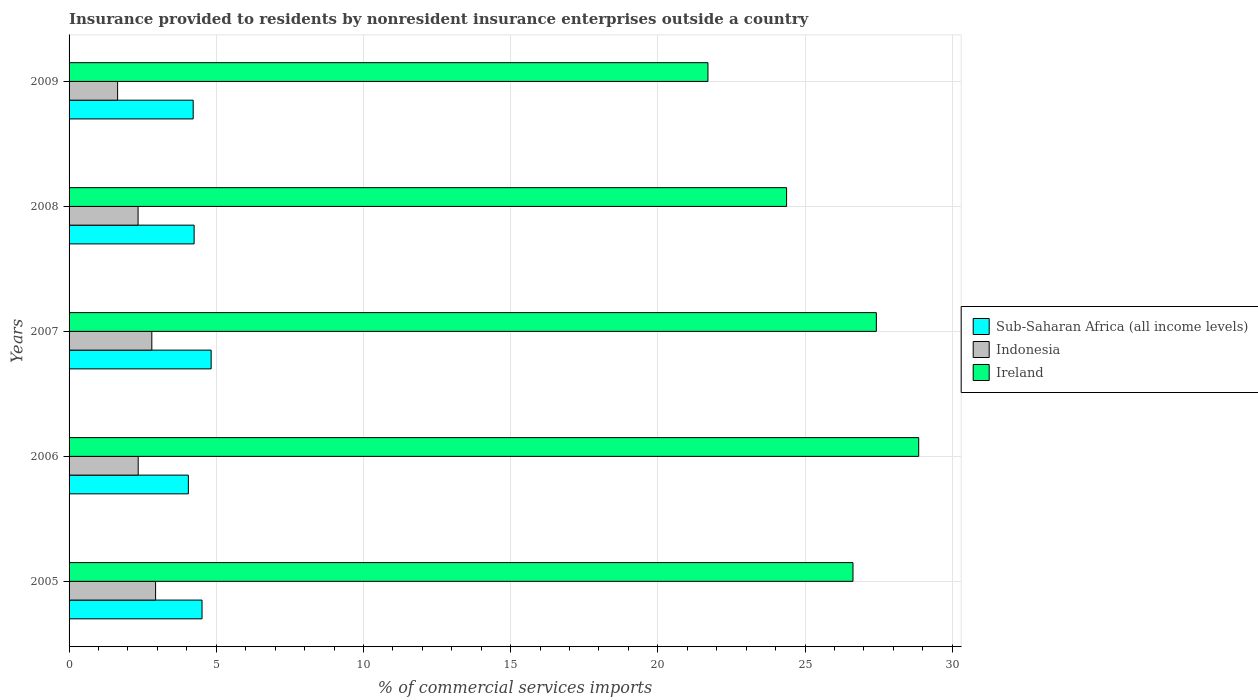How many different coloured bars are there?
Offer a terse response. 3. How many groups of bars are there?
Make the answer very short. 5. Are the number of bars per tick equal to the number of legend labels?
Make the answer very short. Yes. How many bars are there on the 5th tick from the bottom?
Give a very brief answer. 3. What is the label of the 5th group of bars from the top?
Offer a very short reply. 2005. What is the Insurance provided to residents in Ireland in 2008?
Give a very brief answer. 24.37. Across all years, what is the maximum Insurance provided to residents in Sub-Saharan Africa (all income levels)?
Keep it short and to the point. 4.83. Across all years, what is the minimum Insurance provided to residents in Indonesia?
Your answer should be compact. 1.65. In which year was the Insurance provided to residents in Sub-Saharan Africa (all income levels) maximum?
Your response must be concise. 2007. In which year was the Insurance provided to residents in Indonesia minimum?
Your response must be concise. 2009. What is the total Insurance provided to residents in Sub-Saharan Africa (all income levels) in the graph?
Your answer should be compact. 21.86. What is the difference between the Insurance provided to residents in Sub-Saharan Africa (all income levels) in 2005 and that in 2009?
Your response must be concise. 0.3. What is the difference between the Insurance provided to residents in Sub-Saharan Africa (all income levels) in 2006 and the Insurance provided to residents in Ireland in 2005?
Offer a terse response. -22.58. What is the average Insurance provided to residents in Indonesia per year?
Ensure brevity in your answer.  2.42. In the year 2008, what is the difference between the Insurance provided to residents in Ireland and Insurance provided to residents in Indonesia?
Your answer should be compact. 22.03. In how many years, is the Insurance provided to residents in Indonesia greater than 2 %?
Provide a succinct answer. 4. What is the ratio of the Insurance provided to residents in Sub-Saharan Africa (all income levels) in 2008 to that in 2009?
Give a very brief answer. 1.01. Is the Insurance provided to residents in Sub-Saharan Africa (all income levels) in 2005 less than that in 2009?
Make the answer very short. No. Is the difference between the Insurance provided to residents in Ireland in 2006 and 2009 greater than the difference between the Insurance provided to residents in Indonesia in 2006 and 2009?
Offer a terse response. Yes. What is the difference between the highest and the second highest Insurance provided to residents in Sub-Saharan Africa (all income levels)?
Ensure brevity in your answer.  0.31. What is the difference between the highest and the lowest Insurance provided to residents in Indonesia?
Provide a succinct answer. 1.29. In how many years, is the Insurance provided to residents in Sub-Saharan Africa (all income levels) greater than the average Insurance provided to residents in Sub-Saharan Africa (all income levels) taken over all years?
Your answer should be compact. 2. Is the sum of the Insurance provided to residents in Indonesia in 2005 and 2009 greater than the maximum Insurance provided to residents in Sub-Saharan Africa (all income levels) across all years?
Provide a short and direct response. No. What does the 1st bar from the bottom in 2006 represents?
Your answer should be compact. Sub-Saharan Africa (all income levels). How many years are there in the graph?
Keep it short and to the point. 5. Does the graph contain grids?
Offer a very short reply. Yes. Where does the legend appear in the graph?
Provide a succinct answer. Center right. How are the legend labels stacked?
Offer a very short reply. Vertical. What is the title of the graph?
Keep it short and to the point. Insurance provided to residents by nonresident insurance enterprises outside a country. What is the label or title of the X-axis?
Keep it short and to the point. % of commercial services imports. What is the label or title of the Y-axis?
Provide a short and direct response. Years. What is the % of commercial services imports of Sub-Saharan Africa (all income levels) in 2005?
Offer a very short reply. 4.52. What is the % of commercial services imports in Indonesia in 2005?
Your answer should be very brief. 2.94. What is the % of commercial services imports in Ireland in 2005?
Offer a very short reply. 26.63. What is the % of commercial services imports of Sub-Saharan Africa (all income levels) in 2006?
Ensure brevity in your answer.  4.05. What is the % of commercial services imports in Indonesia in 2006?
Provide a succinct answer. 2.35. What is the % of commercial services imports of Ireland in 2006?
Offer a very short reply. 28.86. What is the % of commercial services imports in Sub-Saharan Africa (all income levels) in 2007?
Offer a very short reply. 4.83. What is the % of commercial services imports in Indonesia in 2007?
Ensure brevity in your answer.  2.81. What is the % of commercial services imports of Ireland in 2007?
Give a very brief answer. 27.42. What is the % of commercial services imports in Sub-Saharan Africa (all income levels) in 2008?
Your answer should be compact. 4.25. What is the % of commercial services imports in Indonesia in 2008?
Your response must be concise. 2.34. What is the % of commercial services imports in Ireland in 2008?
Provide a succinct answer. 24.37. What is the % of commercial services imports of Sub-Saharan Africa (all income levels) in 2009?
Make the answer very short. 4.22. What is the % of commercial services imports in Indonesia in 2009?
Give a very brief answer. 1.65. What is the % of commercial services imports in Ireland in 2009?
Keep it short and to the point. 21.7. Across all years, what is the maximum % of commercial services imports in Sub-Saharan Africa (all income levels)?
Offer a very short reply. 4.83. Across all years, what is the maximum % of commercial services imports in Indonesia?
Provide a succinct answer. 2.94. Across all years, what is the maximum % of commercial services imports of Ireland?
Keep it short and to the point. 28.86. Across all years, what is the minimum % of commercial services imports in Sub-Saharan Africa (all income levels)?
Provide a succinct answer. 4.05. Across all years, what is the minimum % of commercial services imports of Indonesia?
Make the answer very short. 1.65. Across all years, what is the minimum % of commercial services imports of Ireland?
Provide a succinct answer. 21.7. What is the total % of commercial services imports of Sub-Saharan Africa (all income levels) in the graph?
Make the answer very short. 21.86. What is the total % of commercial services imports in Indonesia in the graph?
Make the answer very short. 12.09. What is the total % of commercial services imports in Ireland in the graph?
Provide a succinct answer. 128.98. What is the difference between the % of commercial services imports in Sub-Saharan Africa (all income levels) in 2005 and that in 2006?
Give a very brief answer. 0.46. What is the difference between the % of commercial services imports in Indonesia in 2005 and that in 2006?
Make the answer very short. 0.59. What is the difference between the % of commercial services imports in Ireland in 2005 and that in 2006?
Make the answer very short. -2.23. What is the difference between the % of commercial services imports in Sub-Saharan Africa (all income levels) in 2005 and that in 2007?
Provide a short and direct response. -0.31. What is the difference between the % of commercial services imports in Indonesia in 2005 and that in 2007?
Ensure brevity in your answer.  0.13. What is the difference between the % of commercial services imports of Ireland in 2005 and that in 2007?
Your response must be concise. -0.79. What is the difference between the % of commercial services imports of Sub-Saharan Africa (all income levels) in 2005 and that in 2008?
Offer a terse response. 0.27. What is the difference between the % of commercial services imports in Indonesia in 2005 and that in 2008?
Your answer should be very brief. 0.59. What is the difference between the % of commercial services imports in Ireland in 2005 and that in 2008?
Provide a short and direct response. 2.25. What is the difference between the % of commercial services imports in Sub-Saharan Africa (all income levels) in 2005 and that in 2009?
Your answer should be very brief. 0.3. What is the difference between the % of commercial services imports in Indonesia in 2005 and that in 2009?
Offer a very short reply. 1.29. What is the difference between the % of commercial services imports of Ireland in 2005 and that in 2009?
Offer a very short reply. 4.93. What is the difference between the % of commercial services imports of Sub-Saharan Africa (all income levels) in 2006 and that in 2007?
Your response must be concise. -0.77. What is the difference between the % of commercial services imports of Indonesia in 2006 and that in 2007?
Offer a very short reply. -0.46. What is the difference between the % of commercial services imports in Ireland in 2006 and that in 2007?
Your response must be concise. 1.44. What is the difference between the % of commercial services imports of Sub-Saharan Africa (all income levels) in 2006 and that in 2008?
Give a very brief answer. -0.2. What is the difference between the % of commercial services imports in Indonesia in 2006 and that in 2008?
Ensure brevity in your answer.  0. What is the difference between the % of commercial services imports of Ireland in 2006 and that in 2008?
Ensure brevity in your answer.  4.49. What is the difference between the % of commercial services imports in Sub-Saharan Africa (all income levels) in 2006 and that in 2009?
Ensure brevity in your answer.  -0.16. What is the difference between the % of commercial services imports of Indonesia in 2006 and that in 2009?
Provide a short and direct response. 0.7. What is the difference between the % of commercial services imports of Ireland in 2006 and that in 2009?
Your answer should be very brief. 7.16. What is the difference between the % of commercial services imports of Sub-Saharan Africa (all income levels) in 2007 and that in 2008?
Keep it short and to the point. 0.58. What is the difference between the % of commercial services imports in Indonesia in 2007 and that in 2008?
Keep it short and to the point. 0.47. What is the difference between the % of commercial services imports of Ireland in 2007 and that in 2008?
Ensure brevity in your answer.  3.05. What is the difference between the % of commercial services imports in Sub-Saharan Africa (all income levels) in 2007 and that in 2009?
Offer a terse response. 0.61. What is the difference between the % of commercial services imports of Indonesia in 2007 and that in 2009?
Provide a succinct answer. 1.16. What is the difference between the % of commercial services imports in Ireland in 2007 and that in 2009?
Offer a very short reply. 5.72. What is the difference between the % of commercial services imports of Sub-Saharan Africa (all income levels) in 2008 and that in 2009?
Your answer should be very brief. 0.03. What is the difference between the % of commercial services imports in Indonesia in 2008 and that in 2009?
Provide a succinct answer. 0.69. What is the difference between the % of commercial services imports of Ireland in 2008 and that in 2009?
Give a very brief answer. 2.67. What is the difference between the % of commercial services imports in Sub-Saharan Africa (all income levels) in 2005 and the % of commercial services imports in Indonesia in 2006?
Provide a succinct answer. 2.17. What is the difference between the % of commercial services imports in Sub-Saharan Africa (all income levels) in 2005 and the % of commercial services imports in Ireland in 2006?
Your answer should be compact. -24.34. What is the difference between the % of commercial services imports in Indonesia in 2005 and the % of commercial services imports in Ireland in 2006?
Make the answer very short. -25.92. What is the difference between the % of commercial services imports in Sub-Saharan Africa (all income levels) in 2005 and the % of commercial services imports in Indonesia in 2007?
Make the answer very short. 1.7. What is the difference between the % of commercial services imports in Sub-Saharan Africa (all income levels) in 2005 and the % of commercial services imports in Ireland in 2007?
Your answer should be compact. -22.9. What is the difference between the % of commercial services imports of Indonesia in 2005 and the % of commercial services imports of Ireland in 2007?
Your answer should be very brief. -24.48. What is the difference between the % of commercial services imports in Sub-Saharan Africa (all income levels) in 2005 and the % of commercial services imports in Indonesia in 2008?
Ensure brevity in your answer.  2.17. What is the difference between the % of commercial services imports in Sub-Saharan Africa (all income levels) in 2005 and the % of commercial services imports in Ireland in 2008?
Give a very brief answer. -19.86. What is the difference between the % of commercial services imports in Indonesia in 2005 and the % of commercial services imports in Ireland in 2008?
Your answer should be compact. -21.43. What is the difference between the % of commercial services imports of Sub-Saharan Africa (all income levels) in 2005 and the % of commercial services imports of Indonesia in 2009?
Your answer should be compact. 2.87. What is the difference between the % of commercial services imports in Sub-Saharan Africa (all income levels) in 2005 and the % of commercial services imports in Ireland in 2009?
Your response must be concise. -17.18. What is the difference between the % of commercial services imports of Indonesia in 2005 and the % of commercial services imports of Ireland in 2009?
Give a very brief answer. -18.76. What is the difference between the % of commercial services imports in Sub-Saharan Africa (all income levels) in 2006 and the % of commercial services imports in Indonesia in 2007?
Provide a succinct answer. 1.24. What is the difference between the % of commercial services imports of Sub-Saharan Africa (all income levels) in 2006 and the % of commercial services imports of Ireland in 2007?
Provide a short and direct response. -23.37. What is the difference between the % of commercial services imports in Indonesia in 2006 and the % of commercial services imports in Ireland in 2007?
Ensure brevity in your answer.  -25.07. What is the difference between the % of commercial services imports of Sub-Saharan Africa (all income levels) in 2006 and the % of commercial services imports of Indonesia in 2008?
Your answer should be very brief. 1.71. What is the difference between the % of commercial services imports of Sub-Saharan Africa (all income levels) in 2006 and the % of commercial services imports of Ireland in 2008?
Your answer should be compact. -20.32. What is the difference between the % of commercial services imports of Indonesia in 2006 and the % of commercial services imports of Ireland in 2008?
Your answer should be compact. -22.02. What is the difference between the % of commercial services imports of Sub-Saharan Africa (all income levels) in 2006 and the % of commercial services imports of Indonesia in 2009?
Your answer should be very brief. 2.4. What is the difference between the % of commercial services imports in Sub-Saharan Africa (all income levels) in 2006 and the % of commercial services imports in Ireland in 2009?
Your answer should be compact. -17.65. What is the difference between the % of commercial services imports of Indonesia in 2006 and the % of commercial services imports of Ireland in 2009?
Offer a very short reply. -19.35. What is the difference between the % of commercial services imports in Sub-Saharan Africa (all income levels) in 2007 and the % of commercial services imports in Indonesia in 2008?
Provide a short and direct response. 2.48. What is the difference between the % of commercial services imports of Sub-Saharan Africa (all income levels) in 2007 and the % of commercial services imports of Ireland in 2008?
Your answer should be very brief. -19.55. What is the difference between the % of commercial services imports of Indonesia in 2007 and the % of commercial services imports of Ireland in 2008?
Your answer should be very brief. -21.56. What is the difference between the % of commercial services imports in Sub-Saharan Africa (all income levels) in 2007 and the % of commercial services imports in Indonesia in 2009?
Ensure brevity in your answer.  3.18. What is the difference between the % of commercial services imports in Sub-Saharan Africa (all income levels) in 2007 and the % of commercial services imports in Ireland in 2009?
Offer a very short reply. -16.88. What is the difference between the % of commercial services imports in Indonesia in 2007 and the % of commercial services imports in Ireland in 2009?
Offer a terse response. -18.89. What is the difference between the % of commercial services imports of Sub-Saharan Africa (all income levels) in 2008 and the % of commercial services imports of Indonesia in 2009?
Ensure brevity in your answer.  2.6. What is the difference between the % of commercial services imports in Sub-Saharan Africa (all income levels) in 2008 and the % of commercial services imports in Ireland in 2009?
Ensure brevity in your answer.  -17.45. What is the difference between the % of commercial services imports in Indonesia in 2008 and the % of commercial services imports in Ireland in 2009?
Provide a succinct answer. -19.36. What is the average % of commercial services imports of Sub-Saharan Africa (all income levels) per year?
Provide a succinct answer. 4.37. What is the average % of commercial services imports in Indonesia per year?
Ensure brevity in your answer.  2.42. What is the average % of commercial services imports of Ireland per year?
Keep it short and to the point. 25.8. In the year 2005, what is the difference between the % of commercial services imports in Sub-Saharan Africa (all income levels) and % of commercial services imports in Indonesia?
Ensure brevity in your answer.  1.58. In the year 2005, what is the difference between the % of commercial services imports of Sub-Saharan Africa (all income levels) and % of commercial services imports of Ireland?
Provide a succinct answer. -22.11. In the year 2005, what is the difference between the % of commercial services imports of Indonesia and % of commercial services imports of Ireland?
Offer a terse response. -23.69. In the year 2006, what is the difference between the % of commercial services imports of Sub-Saharan Africa (all income levels) and % of commercial services imports of Indonesia?
Your answer should be very brief. 1.7. In the year 2006, what is the difference between the % of commercial services imports of Sub-Saharan Africa (all income levels) and % of commercial services imports of Ireland?
Make the answer very short. -24.81. In the year 2006, what is the difference between the % of commercial services imports in Indonesia and % of commercial services imports in Ireland?
Provide a succinct answer. -26.51. In the year 2007, what is the difference between the % of commercial services imports in Sub-Saharan Africa (all income levels) and % of commercial services imports in Indonesia?
Keep it short and to the point. 2.01. In the year 2007, what is the difference between the % of commercial services imports of Sub-Saharan Africa (all income levels) and % of commercial services imports of Ireland?
Make the answer very short. -22.59. In the year 2007, what is the difference between the % of commercial services imports in Indonesia and % of commercial services imports in Ireland?
Provide a succinct answer. -24.61. In the year 2008, what is the difference between the % of commercial services imports in Sub-Saharan Africa (all income levels) and % of commercial services imports in Indonesia?
Ensure brevity in your answer.  1.9. In the year 2008, what is the difference between the % of commercial services imports of Sub-Saharan Africa (all income levels) and % of commercial services imports of Ireland?
Provide a succinct answer. -20.12. In the year 2008, what is the difference between the % of commercial services imports in Indonesia and % of commercial services imports in Ireland?
Provide a short and direct response. -22.03. In the year 2009, what is the difference between the % of commercial services imports in Sub-Saharan Africa (all income levels) and % of commercial services imports in Indonesia?
Your answer should be compact. 2.57. In the year 2009, what is the difference between the % of commercial services imports of Sub-Saharan Africa (all income levels) and % of commercial services imports of Ireland?
Your response must be concise. -17.49. In the year 2009, what is the difference between the % of commercial services imports of Indonesia and % of commercial services imports of Ireland?
Offer a very short reply. -20.05. What is the ratio of the % of commercial services imports of Sub-Saharan Africa (all income levels) in 2005 to that in 2006?
Your answer should be very brief. 1.11. What is the ratio of the % of commercial services imports in Indonesia in 2005 to that in 2006?
Ensure brevity in your answer.  1.25. What is the ratio of the % of commercial services imports of Ireland in 2005 to that in 2006?
Provide a succinct answer. 0.92. What is the ratio of the % of commercial services imports in Sub-Saharan Africa (all income levels) in 2005 to that in 2007?
Offer a very short reply. 0.94. What is the ratio of the % of commercial services imports in Indonesia in 2005 to that in 2007?
Provide a succinct answer. 1.05. What is the ratio of the % of commercial services imports in Ireland in 2005 to that in 2007?
Offer a very short reply. 0.97. What is the ratio of the % of commercial services imports in Sub-Saharan Africa (all income levels) in 2005 to that in 2008?
Provide a succinct answer. 1.06. What is the ratio of the % of commercial services imports of Indonesia in 2005 to that in 2008?
Give a very brief answer. 1.25. What is the ratio of the % of commercial services imports of Ireland in 2005 to that in 2008?
Your answer should be compact. 1.09. What is the ratio of the % of commercial services imports in Sub-Saharan Africa (all income levels) in 2005 to that in 2009?
Give a very brief answer. 1.07. What is the ratio of the % of commercial services imports of Indonesia in 2005 to that in 2009?
Your response must be concise. 1.78. What is the ratio of the % of commercial services imports in Ireland in 2005 to that in 2009?
Offer a very short reply. 1.23. What is the ratio of the % of commercial services imports of Sub-Saharan Africa (all income levels) in 2006 to that in 2007?
Offer a terse response. 0.84. What is the ratio of the % of commercial services imports of Indonesia in 2006 to that in 2007?
Your answer should be compact. 0.84. What is the ratio of the % of commercial services imports of Ireland in 2006 to that in 2007?
Provide a succinct answer. 1.05. What is the ratio of the % of commercial services imports in Sub-Saharan Africa (all income levels) in 2006 to that in 2008?
Offer a very short reply. 0.95. What is the ratio of the % of commercial services imports in Ireland in 2006 to that in 2008?
Provide a short and direct response. 1.18. What is the ratio of the % of commercial services imports in Sub-Saharan Africa (all income levels) in 2006 to that in 2009?
Provide a succinct answer. 0.96. What is the ratio of the % of commercial services imports of Indonesia in 2006 to that in 2009?
Keep it short and to the point. 1.42. What is the ratio of the % of commercial services imports of Ireland in 2006 to that in 2009?
Ensure brevity in your answer.  1.33. What is the ratio of the % of commercial services imports in Sub-Saharan Africa (all income levels) in 2007 to that in 2008?
Offer a terse response. 1.14. What is the ratio of the % of commercial services imports of Indonesia in 2007 to that in 2008?
Provide a succinct answer. 1.2. What is the ratio of the % of commercial services imports in Ireland in 2007 to that in 2008?
Your response must be concise. 1.13. What is the ratio of the % of commercial services imports of Sub-Saharan Africa (all income levels) in 2007 to that in 2009?
Provide a succinct answer. 1.14. What is the ratio of the % of commercial services imports in Indonesia in 2007 to that in 2009?
Your response must be concise. 1.71. What is the ratio of the % of commercial services imports in Ireland in 2007 to that in 2009?
Make the answer very short. 1.26. What is the ratio of the % of commercial services imports of Sub-Saharan Africa (all income levels) in 2008 to that in 2009?
Provide a succinct answer. 1.01. What is the ratio of the % of commercial services imports in Indonesia in 2008 to that in 2009?
Your answer should be compact. 1.42. What is the ratio of the % of commercial services imports in Ireland in 2008 to that in 2009?
Your answer should be very brief. 1.12. What is the difference between the highest and the second highest % of commercial services imports in Sub-Saharan Africa (all income levels)?
Ensure brevity in your answer.  0.31. What is the difference between the highest and the second highest % of commercial services imports in Indonesia?
Offer a terse response. 0.13. What is the difference between the highest and the second highest % of commercial services imports in Ireland?
Your answer should be compact. 1.44. What is the difference between the highest and the lowest % of commercial services imports in Sub-Saharan Africa (all income levels)?
Make the answer very short. 0.77. What is the difference between the highest and the lowest % of commercial services imports in Indonesia?
Your answer should be very brief. 1.29. What is the difference between the highest and the lowest % of commercial services imports of Ireland?
Make the answer very short. 7.16. 